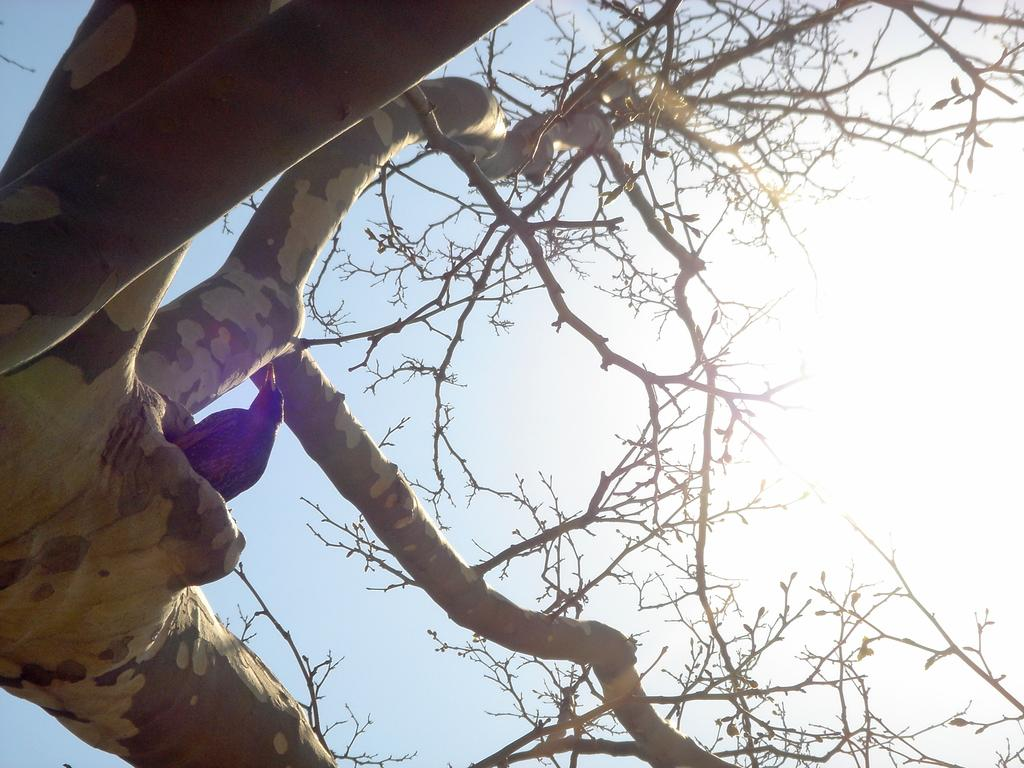What type of animal can be seen in the image? There is a bird in the image. Where is the bird located? The bird is in a hole in a tree trunk. What can be seen in the background of the image? There is a sky visible in the background of the image. What is the condition of the sky in the image? Sunlight is present in the sky. What type of insect can be seen playing baseball in the image? There is no insect or baseball present in the image; it features a bird in a tree trunk with a visible sky. 